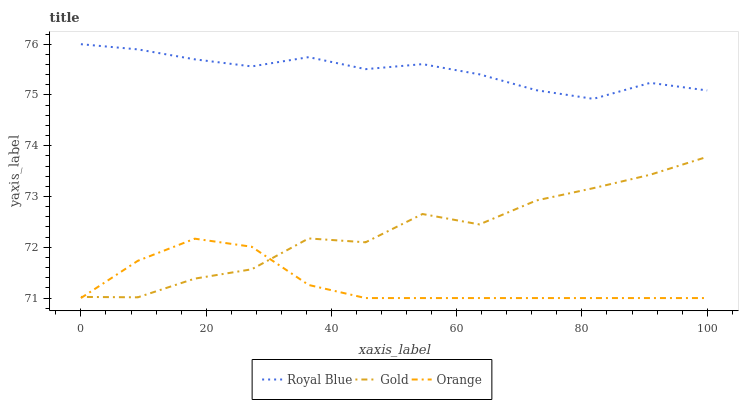Does Orange have the minimum area under the curve?
Answer yes or no. Yes. Does Royal Blue have the maximum area under the curve?
Answer yes or no. Yes. Does Gold have the minimum area under the curve?
Answer yes or no. No. Does Gold have the maximum area under the curve?
Answer yes or no. No. Is Orange the smoothest?
Answer yes or no. Yes. Is Gold the roughest?
Answer yes or no. Yes. Is Royal Blue the smoothest?
Answer yes or no. No. Is Royal Blue the roughest?
Answer yes or no. No. Does Orange have the lowest value?
Answer yes or no. Yes. Does Gold have the lowest value?
Answer yes or no. No. Does Royal Blue have the highest value?
Answer yes or no. Yes. Does Gold have the highest value?
Answer yes or no. No. Is Orange less than Royal Blue?
Answer yes or no. Yes. Is Royal Blue greater than Orange?
Answer yes or no. Yes. Does Orange intersect Gold?
Answer yes or no. Yes. Is Orange less than Gold?
Answer yes or no. No. Is Orange greater than Gold?
Answer yes or no. No. Does Orange intersect Royal Blue?
Answer yes or no. No. 